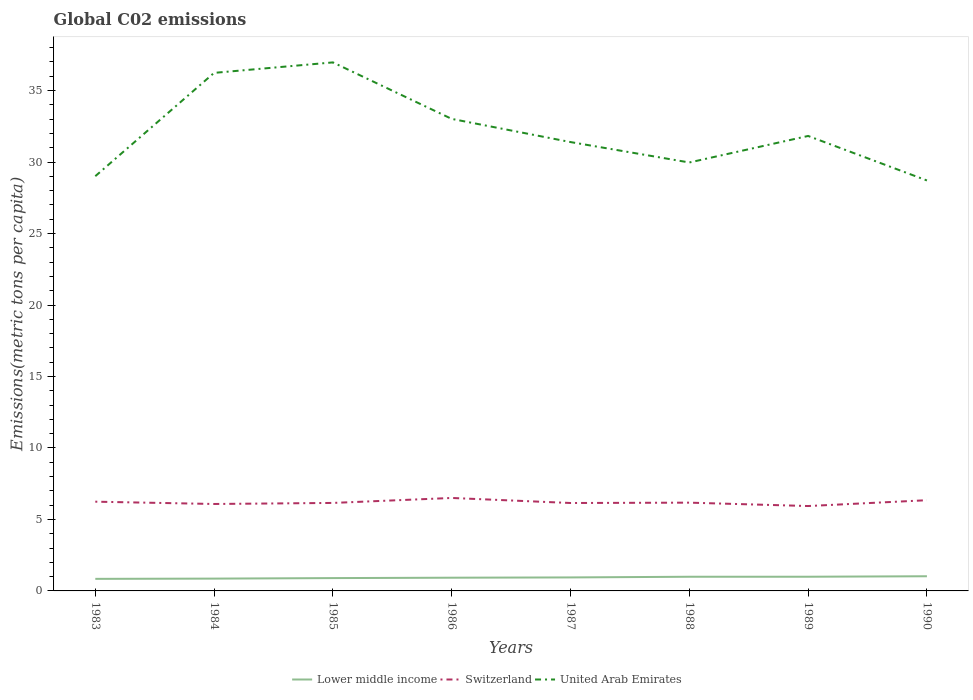Across all years, what is the maximum amount of CO2 emitted in in Lower middle income?
Ensure brevity in your answer.  0.84. What is the total amount of CO2 emitted in in Lower middle income in the graph?
Provide a succinct answer. -0.03. What is the difference between the highest and the second highest amount of CO2 emitted in in Lower middle income?
Give a very brief answer. 0.18. Is the amount of CO2 emitted in in Switzerland strictly greater than the amount of CO2 emitted in in Lower middle income over the years?
Offer a terse response. No. How many years are there in the graph?
Give a very brief answer. 8. How are the legend labels stacked?
Give a very brief answer. Horizontal. What is the title of the graph?
Provide a short and direct response. Global C02 emissions. What is the label or title of the X-axis?
Offer a terse response. Years. What is the label or title of the Y-axis?
Offer a terse response. Emissions(metric tons per capita). What is the Emissions(metric tons per capita) of Lower middle income in 1983?
Your response must be concise. 0.84. What is the Emissions(metric tons per capita) of Switzerland in 1983?
Provide a succinct answer. 6.24. What is the Emissions(metric tons per capita) of United Arab Emirates in 1983?
Keep it short and to the point. 29.01. What is the Emissions(metric tons per capita) of Lower middle income in 1984?
Keep it short and to the point. 0.86. What is the Emissions(metric tons per capita) in Switzerland in 1984?
Give a very brief answer. 6.08. What is the Emissions(metric tons per capita) in United Arab Emirates in 1984?
Your answer should be compact. 36.24. What is the Emissions(metric tons per capita) of Lower middle income in 1985?
Your answer should be very brief. 0.9. What is the Emissions(metric tons per capita) of Switzerland in 1985?
Your answer should be very brief. 6.16. What is the Emissions(metric tons per capita) in United Arab Emirates in 1985?
Ensure brevity in your answer.  36.97. What is the Emissions(metric tons per capita) in Lower middle income in 1986?
Your answer should be very brief. 0.92. What is the Emissions(metric tons per capita) in Switzerland in 1986?
Make the answer very short. 6.5. What is the Emissions(metric tons per capita) in United Arab Emirates in 1986?
Your answer should be very brief. 33.02. What is the Emissions(metric tons per capita) of Lower middle income in 1987?
Your response must be concise. 0.94. What is the Emissions(metric tons per capita) of Switzerland in 1987?
Keep it short and to the point. 6.15. What is the Emissions(metric tons per capita) in United Arab Emirates in 1987?
Offer a terse response. 31.4. What is the Emissions(metric tons per capita) in Lower middle income in 1988?
Provide a short and direct response. 0.99. What is the Emissions(metric tons per capita) of Switzerland in 1988?
Offer a very short reply. 6.17. What is the Emissions(metric tons per capita) of United Arab Emirates in 1988?
Offer a very short reply. 29.97. What is the Emissions(metric tons per capita) of Lower middle income in 1989?
Keep it short and to the point. 0.99. What is the Emissions(metric tons per capita) in Switzerland in 1989?
Give a very brief answer. 5.94. What is the Emissions(metric tons per capita) of United Arab Emirates in 1989?
Ensure brevity in your answer.  31.82. What is the Emissions(metric tons per capita) of Lower middle income in 1990?
Your answer should be compact. 1.03. What is the Emissions(metric tons per capita) in Switzerland in 1990?
Your answer should be very brief. 6.35. What is the Emissions(metric tons per capita) of United Arab Emirates in 1990?
Provide a succinct answer. 28.71. Across all years, what is the maximum Emissions(metric tons per capita) of Lower middle income?
Offer a terse response. 1.03. Across all years, what is the maximum Emissions(metric tons per capita) of Switzerland?
Your answer should be compact. 6.5. Across all years, what is the maximum Emissions(metric tons per capita) of United Arab Emirates?
Offer a terse response. 36.97. Across all years, what is the minimum Emissions(metric tons per capita) of Lower middle income?
Provide a succinct answer. 0.84. Across all years, what is the minimum Emissions(metric tons per capita) of Switzerland?
Provide a short and direct response. 5.94. Across all years, what is the minimum Emissions(metric tons per capita) of United Arab Emirates?
Your answer should be very brief. 28.71. What is the total Emissions(metric tons per capita) of Lower middle income in the graph?
Your response must be concise. 7.48. What is the total Emissions(metric tons per capita) of Switzerland in the graph?
Give a very brief answer. 49.59. What is the total Emissions(metric tons per capita) in United Arab Emirates in the graph?
Your answer should be compact. 257.14. What is the difference between the Emissions(metric tons per capita) of Lower middle income in 1983 and that in 1984?
Your answer should be very brief. -0.02. What is the difference between the Emissions(metric tons per capita) of Switzerland in 1983 and that in 1984?
Your answer should be compact. 0.16. What is the difference between the Emissions(metric tons per capita) in United Arab Emirates in 1983 and that in 1984?
Offer a very short reply. -7.23. What is the difference between the Emissions(metric tons per capita) in Lower middle income in 1983 and that in 1985?
Provide a short and direct response. -0.05. What is the difference between the Emissions(metric tons per capita) in Switzerland in 1983 and that in 1985?
Offer a very short reply. 0.09. What is the difference between the Emissions(metric tons per capita) of United Arab Emirates in 1983 and that in 1985?
Give a very brief answer. -7.96. What is the difference between the Emissions(metric tons per capita) of Lower middle income in 1983 and that in 1986?
Provide a short and direct response. -0.08. What is the difference between the Emissions(metric tons per capita) of Switzerland in 1983 and that in 1986?
Offer a terse response. -0.26. What is the difference between the Emissions(metric tons per capita) in United Arab Emirates in 1983 and that in 1986?
Your answer should be very brief. -4.01. What is the difference between the Emissions(metric tons per capita) of Lower middle income in 1983 and that in 1987?
Keep it short and to the point. -0.1. What is the difference between the Emissions(metric tons per capita) in Switzerland in 1983 and that in 1987?
Keep it short and to the point. 0.09. What is the difference between the Emissions(metric tons per capita) of United Arab Emirates in 1983 and that in 1987?
Give a very brief answer. -2.39. What is the difference between the Emissions(metric tons per capita) in Lower middle income in 1983 and that in 1988?
Your answer should be compact. -0.15. What is the difference between the Emissions(metric tons per capita) in Switzerland in 1983 and that in 1988?
Make the answer very short. 0.07. What is the difference between the Emissions(metric tons per capita) in United Arab Emirates in 1983 and that in 1988?
Keep it short and to the point. -0.96. What is the difference between the Emissions(metric tons per capita) of Lower middle income in 1983 and that in 1989?
Make the answer very short. -0.15. What is the difference between the Emissions(metric tons per capita) in Switzerland in 1983 and that in 1989?
Your response must be concise. 0.3. What is the difference between the Emissions(metric tons per capita) in United Arab Emirates in 1983 and that in 1989?
Your answer should be compact. -2.81. What is the difference between the Emissions(metric tons per capita) in Lower middle income in 1983 and that in 1990?
Your answer should be compact. -0.18. What is the difference between the Emissions(metric tons per capita) in Switzerland in 1983 and that in 1990?
Your answer should be very brief. -0.1. What is the difference between the Emissions(metric tons per capita) in United Arab Emirates in 1983 and that in 1990?
Your response must be concise. 0.3. What is the difference between the Emissions(metric tons per capita) in Lower middle income in 1984 and that in 1985?
Make the answer very short. -0.04. What is the difference between the Emissions(metric tons per capita) of Switzerland in 1984 and that in 1985?
Give a very brief answer. -0.07. What is the difference between the Emissions(metric tons per capita) in United Arab Emirates in 1984 and that in 1985?
Offer a very short reply. -0.73. What is the difference between the Emissions(metric tons per capita) of Lower middle income in 1984 and that in 1986?
Provide a succinct answer. -0.06. What is the difference between the Emissions(metric tons per capita) in Switzerland in 1984 and that in 1986?
Provide a succinct answer. -0.42. What is the difference between the Emissions(metric tons per capita) of United Arab Emirates in 1984 and that in 1986?
Your response must be concise. 3.22. What is the difference between the Emissions(metric tons per capita) in Lower middle income in 1984 and that in 1987?
Offer a terse response. -0.08. What is the difference between the Emissions(metric tons per capita) in Switzerland in 1984 and that in 1987?
Ensure brevity in your answer.  -0.07. What is the difference between the Emissions(metric tons per capita) of United Arab Emirates in 1984 and that in 1987?
Provide a short and direct response. 4.84. What is the difference between the Emissions(metric tons per capita) of Lower middle income in 1984 and that in 1988?
Make the answer very short. -0.13. What is the difference between the Emissions(metric tons per capita) in Switzerland in 1984 and that in 1988?
Provide a succinct answer. -0.09. What is the difference between the Emissions(metric tons per capita) in United Arab Emirates in 1984 and that in 1988?
Provide a short and direct response. 6.27. What is the difference between the Emissions(metric tons per capita) in Lower middle income in 1984 and that in 1989?
Keep it short and to the point. -0.13. What is the difference between the Emissions(metric tons per capita) of Switzerland in 1984 and that in 1989?
Provide a succinct answer. 0.14. What is the difference between the Emissions(metric tons per capita) in United Arab Emirates in 1984 and that in 1989?
Offer a very short reply. 4.41. What is the difference between the Emissions(metric tons per capita) in Lower middle income in 1984 and that in 1990?
Your answer should be very brief. -0.16. What is the difference between the Emissions(metric tons per capita) in Switzerland in 1984 and that in 1990?
Provide a succinct answer. -0.26. What is the difference between the Emissions(metric tons per capita) in United Arab Emirates in 1984 and that in 1990?
Your response must be concise. 7.53. What is the difference between the Emissions(metric tons per capita) of Lower middle income in 1985 and that in 1986?
Ensure brevity in your answer.  -0.03. What is the difference between the Emissions(metric tons per capita) of Switzerland in 1985 and that in 1986?
Your response must be concise. -0.35. What is the difference between the Emissions(metric tons per capita) of United Arab Emirates in 1985 and that in 1986?
Provide a short and direct response. 3.95. What is the difference between the Emissions(metric tons per capita) in Lower middle income in 1985 and that in 1987?
Provide a succinct answer. -0.05. What is the difference between the Emissions(metric tons per capita) of Switzerland in 1985 and that in 1987?
Offer a terse response. 0.01. What is the difference between the Emissions(metric tons per capita) of United Arab Emirates in 1985 and that in 1987?
Ensure brevity in your answer.  5.57. What is the difference between the Emissions(metric tons per capita) of Lower middle income in 1985 and that in 1988?
Your answer should be compact. -0.09. What is the difference between the Emissions(metric tons per capita) in Switzerland in 1985 and that in 1988?
Ensure brevity in your answer.  -0.02. What is the difference between the Emissions(metric tons per capita) in United Arab Emirates in 1985 and that in 1988?
Give a very brief answer. 7. What is the difference between the Emissions(metric tons per capita) of Lower middle income in 1985 and that in 1989?
Your response must be concise. -0.09. What is the difference between the Emissions(metric tons per capita) of Switzerland in 1985 and that in 1989?
Your answer should be very brief. 0.22. What is the difference between the Emissions(metric tons per capita) in United Arab Emirates in 1985 and that in 1989?
Offer a very short reply. 5.15. What is the difference between the Emissions(metric tons per capita) in Lower middle income in 1985 and that in 1990?
Your answer should be compact. -0.13. What is the difference between the Emissions(metric tons per capita) of Switzerland in 1985 and that in 1990?
Your answer should be compact. -0.19. What is the difference between the Emissions(metric tons per capita) of United Arab Emirates in 1985 and that in 1990?
Your answer should be compact. 8.26. What is the difference between the Emissions(metric tons per capita) in Lower middle income in 1986 and that in 1987?
Provide a succinct answer. -0.02. What is the difference between the Emissions(metric tons per capita) in Switzerland in 1986 and that in 1987?
Make the answer very short. 0.35. What is the difference between the Emissions(metric tons per capita) of United Arab Emirates in 1986 and that in 1987?
Give a very brief answer. 1.62. What is the difference between the Emissions(metric tons per capita) in Lower middle income in 1986 and that in 1988?
Make the answer very short. -0.07. What is the difference between the Emissions(metric tons per capita) in Switzerland in 1986 and that in 1988?
Your answer should be compact. 0.33. What is the difference between the Emissions(metric tons per capita) of United Arab Emirates in 1986 and that in 1988?
Make the answer very short. 3.05. What is the difference between the Emissions(metric tons per capita) in Lower middle income in 1986 and that in 1989?
Ensure brevity in your answer.  -0.07. What is the difference between the Emissions(metric tons per capita) of Switzerland in 1986 and that in 1989?
Give a very brief answer. 0.56. What is the difference between the Emissions(metric tons per capita) of United Arab Emirates in 1986 and that in 1989?
Provide a succinct answer. 1.19. What is the difference between the Emissions(metric tons per capita) in Lower middle income in 1986 and that in 1990?
Your response must be concise. -0.1. What is the difference between the Emissions(metric tons per capita) in Switzerland in 1986 and that in 1990?
Make the answer very short. 0.16. What is the difference between the Emissions(metric tons per capita) in United Arab Emirates in 1986 and that in 1990?
Provide a short and direct response. 4.31. What is the difference between the Emissions(metric tons per capita) of Lower middle income in 1987 and that in 1988?
Offer a terse response. -0.05. What is the difference between the Emissions(metric tons per capita) in Switzerland in 1987 and that in 1988?
Provide a succinct answer. -0.02. What is the difference between the Emissions(metric tons per capita) in United Arab Emirates in 1987 and that in 1988?
Provide a short and direct response. 1.43. What is the difference between the Emissions(metric tons per capita) in Lower middle income in 1987 and that in 1989?
Your response must be concise. -0.05. What is the difference between the Emissions(metric tons per capita) in Switzerland in 1987 and that in 1989?
Your answer should be compact. 0.21. What is the difference between the Emissions(metric tons per capita) of United Arab Emirates in 1987 and that in 1989?
Provide a succinct answer. -0.43. What is the difference between the Emissions(metric tons per capita) in Lower middle income in 1987 and that in 1990?
Offer a terse response. -0.08. What is the difference between the Emissions(metric tons per capita) of Switzerland in 1987 and that in 1990?
Keep it short and to the point. -0.2. What is the difference between the Emissions(metric tons per capita) in United Arab Emirates in 1987 and that in 1990?
Give a very brief answer. 2.69. What is the difference between the Emissions(metric tons per capita) in Lower middle income in 1988 and that in 1989?
Offer a terse response. -0. What is the difference between the Emissions(metric tons per capita) in Switzerland in 1988 and that in 1989?
Offer a terse response. 0.24. What is the difference between the Emissions(metric tons per capita) in United Arab Emirates in 1988 and that in 1989?
Your response must be concise. -1.86. What is the difference between the Emissions(metric tons per capita) in Lower middle income in 1988 and that in 1990?
Offer a very short reply. -0.04. What is the difference between the Emissions(metric tons per capita) in Switzerland in 1988 and that in 1990?
Give a very brief answer. -0.17. What is the difference between the Emissions(metric tons per capita) in United Arab Emirates in 1988 and that in 1990?
Keep it short and to the point. 1.26. What is the difference between the Emissions(metric tons per capita) in Lower middle income in 1989 and that in 1990?
Ensure brevity in your answer.  -0.03. What is the difference between the Emissions(metric tons per capita) of Switzerland in 1989 and that in 1990?
Ensure brevity in your answer.  -0.41. What is the difference between the Emissions(metric tons per capita) in United Arab Emirates in 1989 and that in 1990?
Provide a succinct answer. 3.11. What is the difference between the Emissions(metric tons per capita) of Lower middle income in 1983 and the Emissions(metric tons per capita) of Switzerland in 1984?
Keep it short and to the point. -5.24. What is the difference between the Emissions(metric tons per capita) in Lower middle income in 1983 and the Emissions(metric tons per capita) in United Arab Emirates in 1984?
Provide a short and direct response. -35.39. What is the difference between the Emissions(metric tons per capita) in Switzerland in 1983 and the Emissions(metric tons per capita) in United Arab Emirates in 1984?
Offer a terse response. -30. What is the difference between the Emissions(metric tons per capita) in Lower middle income in 1983 and the Emissions(metric tons per capita) in Switzerland in 1985?
Offer a terse response. -5.31. What is the difference between the Emissions(metric tons per capita) of Lower middle income in 1983 and the Emissions(metric tons per capita) of United Arab Emirates in 1985?
Offer a terse response. -36.13. What is the difference between the Emissions(metric tons per capita) in Switzerland in 1983 and the Emissions(metric tons per capita) in United Arab Emirates in 1985?
Offer a terse response. -30.73. What is the difference between the Emissions(metric tons per capita) in Lower middle income in 1983 and the Emissions(metric tons per capita) in Switzerland in 1986?
Your response must be concise. -5.66. What is the difference between the Emissions(metric tons per capita) in Lower middle income in 1983 and the Emissions(metric tons per capita) in United Arab Emirates in 1986?
Offer a very short reply. -32.17. What is the difference between the Emissions(metric tons per capita) in Switzerland in 1983 and the Emissions(metric tons per capita) in United Arab Emirates in 1986?
Your response must be concise. -26.78. What is the difference between the Emissions(metric tons per capita) of Lower middle income in 1983 and the Emissions(metric tons per capita) of Switzerland in 1987?
Provide a succinct answer. -5.31. What is the difference between the Emissions(metric tons per capita) of Lower middle income in 1983 and the Emissions(metric tons per capita) of United Arab Emirates in 1987?
Provide a succinct answer. -30.55. What is the difference between the Emissions(metric tons per capita) of Switzerland in 1983 and the Emissions(metric tons per capita) of United Arab Emirates in 1987?
Keep it short and to the point. -25.16. What is the difference between the Emissions(metric tons per capita) of Lower middle income in 1983 and the Emissions(metric tons per capita) of Switzerland in 1988?
Offer a very short reply. -5.33. What is the difference between the Emissions(metric tons per capita) in Lower middle income in 1983 and the Emissions(metric tons per capita) in United Arab Emirates in 1988?
Make the answer very short. -29.13. What is the difference between the Emissions(metric tons per capita) of Switzerland in 1983 and the Emissions(metric tons per capita) of United Arab Emirates in 1988?
Keep it short and to the point. -23.73. What is the difference between the Emissions(metric tons per capita) of Lower middle income in 1983 and the Emissions(metric tons per capita) of Switzerland in 1989?
Provide a succinct answer. -5.09. What is the difference between the Emissions(metric tons per capita) of Lower middle income in 1983 and the Emissions(metric tons per capita) of United Arab Emirates in 1989?
Offer a terse response. -30.98. What is the difference between the Emissions(metric tons per capita) of Switzerland in 1983 and the Emissions(metric tons per capita) of United Arab Emirates in 1989?
Give a very brief answer. -25.58. What is the difference between the Emissions(metric tons per capita) in Lower middle income in 1983 and the Emissions(metric tons per capita) in Switzerland in 1990?
Your answer should be very brief. -5.5. What is the difference between the Emissions(metric tons per capita) of Lower middle income in 1983 and the Emissions(metric tons per capita) of United Arab Emirates in 1990?
Your answer should be very brief. -27.87. What is the difference between the Emissions(metric tons per capita) of Switzerland in 1983 and the Emissions(metric tons per capita) of United Arab Emirates in 1990?
Make the answer very short. -22.47. What is the difference between the Emissions(metric tons per capita) in Lower middle income in 1984 and the Emissions(metric tons per capita) in Switzerland in 1985?
Provide a short and direct response. -5.29. What is the difference between the Emissions(metric tons per capita) in Lower middle income in 1984 and the Emissions(metric tons per capita) in United Arab Emirates in 1985?
Your answer should be compact. -36.11. What is the difference between the Emissions(metric tons per capita) of Switzerland in 1984 and the Emissions(metric tons per capita) of United Arab Emirates in 1985?
Your response must be concise. -30.89. What is the difference between the Emissions(metric tons per capita) of Lower middle income in 1984 and the Emissions(metric tons per capita) of Switzerland in 1986?
Keep it short and to the point. -5.64. What is the difference between the Emissions(metric tons per capita) of Lower middle income in 1984 and the Emissions(metric tons per capita) of United Arab Emirates in 1986?
Your answer should be very brief. -32.16. What is the difference between the Emissions(metric tons per capita) of Switzerland in 1984 and the Emissions(metric tons per capita) of United Arab Emirates in 1986?
Give a very brief answer. -26.94. What is the difference between the Emissions(metric tons per capita) in Lower middle income in 1984 and the Emissions(metric tons per capita) in Switzerland in 1987?
Offer a terse response. -5.29. What is the difference between the Emissions(metric tons per capita) in Lower middle income in 1984 and the Emissions(metric tons per capita) in United Arab Emirates in 1987?
Ensure brevity in your answer.  -30.54. What is the difference between the Emissions(metric tons per capita) in Switzerland in 1984 and the Emissions(metric tons per capita) in United Arab Emirates in 1987?
Ensure brevity in your answer.  -25.32. What is the difference between the Emissions(metric tons per capita) of Lower middle income in 1984 and the Emissions(metric tons per capita) of Switzerland in 1988?
Give a very brief answer. -5.31. What is the difference between the Emissions(metric tons per capita) in Lower middle income in 1984 and the Emissions(metric tons per capita) in United Arab Emirates in 1988?
Keep it short and to the point. -29.11. What is the difference between the Emissions(metric tons per capita) of Switzerland in 1984 and the Emissions(metric tons per capita) of United Arab Emirates in 1988?
Your answer should be compact. -23.89. What is the difference between the Emissions(metric tons per capita) of Lower middle income in 1984 and the Emissions(metric tons per capita) of Switzerland in 1989?
Your answer should be very brief. -5.08. What is the difference between the Emissions(metric tons per capita) in Lower middle income in 1984 and the Emissions(metric tons per capita) in United Arab Emirates in 1989?
Ensure brevity in your answer.  -30.96. What is the difference between the Emissions(metric tons per capita) of Switzerland in 1984 and the Emissions(metric tons per capita) of United Arab Emirates in 1989?
Make the answer very short. -25.74. What is the difference between the Emissions(metric tons per capita) in Lower middle income in 1984 and the Emissions(metric tons per capita) in Switzerland in 1990?
Offer a very short reply. -5.48. What is the difference between the Emissions(metric tons per capita) in Lower middle income in 1984 and the Emissions(metric tons per capita) in United Arab Emirates in 1990?
Ensure brevity in your answer.  -27.85. What is the difference between the Emissions(metric tons per capita) in Switzerland in 1984 and the Emissions(metric tons per capita) in United Arab Emirates in 1990?
Give a very brief answer. -22.63. What is the difference between the Emissions(metric tons per capita) in Lower middle income in 1985 and the Emissions(metric tons per capita) in Switzerland in 1986?
Your answer should be very brief. -5.61. What is the difference between the Emissions(metric tons per capita) in Lower middle income in 1985 and the Emissions(metric tons per capita) in United Arab Emirates in 1986?
Provide a succinct answer. -32.12. What is the difference between the Emissions(metric tons per capita) in Switzerland in 1985 and the Emissions(metric tons per capita) in United Arab Emirates in 1986?
Give a very brief answer. -26.86. What is the difference between the Emissions(metric tons per capita) of Lower middle income in 1985 and the Emissions(metric tons per capita) of Switzerland in 1987?
Keep it short and to the point. -5.25. What is the difference between the Emissions(metric tons per capita) of Lower middle income in 1985 and the Emissions(metric tons per capita) of United Arab Emirates in 1987?
Make the answer very short. -30.5. What is the difference between the Emissions(metric tons per capita) in Switzerland in 1985 and the Emissions(metric tons per capita) in United Arab Emirates in 1987?
Give a very brief answer. -25.24. What is the difference between the Emissions(metric tons per capita) of Lower middle income in 1985 and the Emissions(metric tons per capita) of Switzerland in 1988?
Make the answer very short. -5.28. What is the difference between the Emissions(metric tons per capita) in Lower middle income in 1985 and the Emissions(metric tons per capita) in United Arab Emirates in 1988?
Keep it short and to the point. -29.07. What is the difference between the Emissions(metric tons per capita) in Switzerland in 1985 and the Emissions(metric tons per capita) in United Arab Emirates in 1988?
Keep it short and to the point. -23.81. What is the difference between the Emissions(metric tons per capita) in Lower middle income in 1985 and the Emissions(metric tons per capita) in Switzerland in 1989?
Give a very brief answer. -5.04. What is the difference between the Emissions(metric tons per capita) in Lower middle income in 1985 and the Emissions(metric tons per capita) in United Arab Emirates in 1989?
Give a very brief answer. -30.93. What is the difference between the Emissions(metric tons per capita) in Switzerland in 1985 and the Emissions(metric tons per capita) in United Arab Emirates in 1989?
Your answer should be very brief. -25.67. What is the difference between the Emissions(metric tons per capita) of Lower middle income in 1985 and the Emissions(metric tons per capita) of Switzerland in 1990?
Offer a very short reply. -5.45. What is the difference between the Emissions(metric tons per capita) of Lower middle income in 1985 and the Emissions(metric tons per capita) of United Arab Emirates in 1990?
Your answer should be very brief. -27.81. What is the difference between the Emissions(metric tons per capita) in Switzerland in 1985 and the Emissions(metric tons per capita) in United Arab Emirates in 1990?
Ensure brevity in your answer.  -22.56. What is the difference between the Emissions(metric tons per capita) of Lower middle income in 1986 and the Emissions(metric tons per capita) of Switzerland in 1987?
Your response must be concise. -5.23. What is the difference between the Emissions(metric tons per capita) in Lower middle income in 1986 and the Emissions(metric tons per capita) in United Arab Emirates in 1987?
Your answer should be very brief. -30.47. What is the difference between the Emissions(metric tons per capita) of Switzerland in 1986 and the Emissions(metric tons per capita) of United Arab Emirates in 1987?
Keep it short and to the point. -24.89. What is the difference between the Emissions(metric tons per capita) of Lower middle income in 1986 and the Emissions(metric tons per capita) of Switzerland in 1988?
Keep it short and to the point. -5.25. What is the difference between the Emissions(metric tons per capita) in Lower middle income in 1986 and the Emissions(metric tons per capita) in United Arab Emirates in 1988?
Offer a terse response. -29.05. What is the difference between the Emissions(metric tons per capita) of Switzerland in 1986 and the Emissions(metric tons per capita) of United Arab Emirates in 1988?
Your answer should be very brief. -23.47. What is the difference between the Emissions(metric tons per capita) in Lower middle income in 1986 and the Emissions(metric tons per capita) in Switzerland in 1989?
Offer a very short reply. -5.01. What is the difference between the Emissions(metric tons per capita) in Lower middle income in 1986 and the Emissions(metric tons per capita) in United Arab Emirates in 1989?
Ensure brevity in your answer.  -30.9. What is the difference between the Emissions(metric tons per capita) of Switzerland in 1986 and the Emissions(metric tons per capita) of United Arab Emirates in 1989?
Give a very brief answer. -25.32. What is the difference between the Emissions(metric tons per capita) of Lower middle income in 1986 and the Emissions(metric tons per capita) of Switzerland in 1990?
Provide a short and direct response. -5.42. What is the difference between the Emissions(metric tons per capita) in Lower middle income in 1986 and the Emissions(metric tons per capita) in United Arab Emirates in 1990?
Keep it short and to the point. -27.79. What is the difference between the Emissions(metric tons per capita) of Switzerland in 1986 and the Emissions(metric tons per capita) of United Arab Emirates in 1990?
Provide a succinct answer. -22.21. What is the difference between the Emissions(metric tons per capita) in Lower middle income in 1987 and the Emissions(metric tons per capita) in Switzerland in 1988?
Give a very brief answer. -5.23. What is the difference between the Emissions(metric tons per capita) in Lower middle income in 1987 and the Emissions(metric tons per capita) in United Arab Emirates in 1988?
Keep it short and to the point. -29.03. What is the difference between the Emissions(metric tons per capita) of Switzerland in 1987 and the Emissions(metric tons per capita) of United Arab Emirates in 1988?
Your answer should be very brief. -23.82. What is the difference between the Emissions(metric tons per capita) of Lower middle income in 1987 and the Emissions(metric tons per capita) of Switzerland in 1989?
Offer a very short reply. -4.99. What is the difference between the Emissions(metric tons per capita) of Lower middle income in 1987 and the Emissions(metric tons per capita) of United Arab Emirates in 1989?
Your response must be concise. -30.88. What is the difference between the Emissions(metric tons per capita) of Switzerland in 1987 and the Emissions(metric tons per capita) of United Arab Emirates in 1989?
Your response must be concise. -25.67. What is the difference between the Emissions(metric tons per capita) in Lower middle income in 1987 and the Emissions(metric tons per capita) in Switzerland in 1990?
Offer a terse response. -5.4. What is the difference between the Emissions(metric tons per capita) of Lower middle income in 1987 and the Emissions(metric tons per capita) of United Arab Emirates in 1990?
Provide a succinct answer. -27.77. What is the difference between the Emissions(metric tons per capita) of Switzerland in 1987 and the Emissions(metric tons per capita) of United Arab Emirates in 1990?
Provide a succinct answer. -22.56. What is the difference between the Emissions(metric tons per capita) in Lower middle income in 1988 and the Emissions(metric tons per capita) in Switzerland in 1989?
Make the answer very short. -4.95. What is the difference between the Emissions(metric tons per capita) of Lower middle income in 1988 and the Emissions(metric tons per capita) of United Arab Emirates in 1989?
Offer a terse response. -30.83. What is the difference between the Emissions(metric tons per capita) of Switzerland in 1988 and the Emissions(metric tons per capita) of United Arab Emirates in 1989?
Offer a terse response. -25.65. What is the difference between the Emissions(metric tons per capita) of Lower middle income in 1988 and the Emissions(metric tons per capita) of Switzerland in 1990?
Keep it short and to the point. -5.35. What is the difference between the Emissions(metric tons per capita) of Lower middle income in 1988 and the Emissions(metric tons per capita) of United Arab Emirates in 1990?
Make the answer very short. -27.72. What is the difference between the Emissions(metric tons per capita) in Switzerland in 1988 and the Emissions(metric tons per capita) in United Arab Emirates in 1990?
Provide a short and direct response. -22.54. What is the difference between the Emissions(metric tons per capita) in Lower middle income in 1989 and the Emissions(metric tons per capita) in Switzerland in 1990?
Your answer should be very brief. -5.35. What is the difference between the Emissions(metric tons per capita) in Lower middle income in 1989 and the Emissions(metric tons per capita) in United Arab Emirates in 1990?
Give a very brief answer. -27.72. What is the difference between the Emissions(metric tons per capita) of Switzerland in 1989 and the Emissions(metric tons per capita) of United Arab Emirates in 1990?
Make the answer very short. -22.77. What is the average Emissions(metric tons per capita) in Lower middle income per year?
Your answer should be compact. 0.94. What is the average Emissions(metric tons per capita) in Switzerland per year?
Your answer should be compact. 6.2. What is the average Emissions(metric tons per capita) in United Arab Emirates per year?
Your response must be concise. 32.14. In the year 1983, what is the difference between the Emissions(metric tons per capita) in Lower middle income and Emissions(metric tons per capita) in Switzerland?
Provide a succinct answer. -5.4. In the year 1983, what is the difference between the Emissions(metric tons per capita) in Lower middle income and Emissions(metric tons per capita) in United Arab Emirates?
Keep it short and to the point. -28.17. In the year 1983, what is the difference between the Emissions(metric tons per capita) in Switzerland and Emissions(metric tons per capita) in United Arab Emirates?
Provide a succinct answer. -22.77. In the year 1984, what is the difference between the Emissions(metric tons per capita) in Lower middle income and Emissions(metric tons per capita) in Switzerland?
Offer a very short reply. -5.22. In the year 1984, what is the difference between the Emissions(metric tons per capita) in Lower middle income and Emissions(metric tons per capita) in United Arab Emirates?
Provide a succinct answer. -35.38. In the year 1984, what is the difference between the Emissions(metric tons per capita) of Switzerland and Emissions(metric tons per capita) of United Arab Emirates?
Provide a short and direct response. -30.16. In the year 1985, what is the difference between the Emissions(metric tons per capita) in Lower middle income and Emissions(metric tons per capita) in Switzerland?
Your answer should be very brief. -5.26. In the year 1985, what is the difference between the Emissions(metric tons per capita) in Lower middle income and Emissions(metric tons per capita) in United Arab Emirates?
Make the answer very short. -36.07. In the year 1985, what is the difference between the Emissions(metric tons per capita) in Switzerland and Emissions(metric tons per capita) in United Arab Emirates?
Provide a short and direct response. -30.82. In the year 1986, what is the difference between the Emissions(metric tons per capita) in Lower middle income and Emissions(metric tons per capita) in Switzerland?
Give a very brief answer. -5.58. In the year 1986, what is the difference between the Emissions(metric tons per capita) in Lower middle income and Emissions(metric tons per capita) in United Arab Emirates?
Offer a very short reply. -32.09. In the year 1986, what is the difference between the Emissions(metric tons per capita) of Switzerland and Emissions(metric tons per capita) of United Arab Emirates?
Provide a succinct answer. -26.52. In the year 1987, what is the difference between the Emissions(metric tons per capita) of Lower middle income and Emissions(metric tons per capita) of Switzerland?
Keep it short and to the point. -5.21. In the year 1987, what is the difference between the Emissions(metric tons per capita) of Lower middle income and Emissions(metric tons per capita) of United Arab Emirates?
Your answer should be very brief. -30.45. In the year 1987, what is the difference between the Emissions(metric tons per capita) in Switzerland and Emissions(metric tons per capita) in United Arab Emirates?
Give a very brief answer. -25.25. In the year 1988, what is the difference between the Emissions(metric tons per capita) in Lower middle income and Emissions(metric tons per capita) in Switzerland?
Keep it short and to the point. -5.18. In the year 1988, what is the difference between the Emissions(metric tons per capita) of Lower middle income and Emissions(metric tons per capita) of United Arab Emirates?
Provide a short and direct response. -28.98. In the year 1988, what is the difference between the Emissions(metric tons per capita) of Switzerland and Emissions(metric tons per capita) of United Arab Emirates?
Your answer should be very brief. -23.79. In the year 1989, what is the difference between the Emissions(metric tons per capita) of Lower middle income and Emissions(metric tons per capita) of Switzerland?
Make the answer very short. -4.95. In the year 1989, what is the difference between the Emissions(metric tons per capita) in Lower middle income and Emissions(metric tons per capita) in United Arab Emirates?
Provide a short and direct response. -30.83. In the year 1989, what is the difference between the Emissions(metric tons per capita) of Switzerland and Emissions(metric tons per capita) of United Arab Emirates?
Your response must be concise. -25.89. In the year 1990, what is the difference between the Emissions(metric tons per capita) of Lower middle income and Emissions(metric tons per capita) of Switzerland?
Provide a short and direct response. -5.32. In the year 1990, what is the difference between the Emissions(metric tons per capita) of Lower middle income and Emissions(metric tons per capita) of United Arab Emirates?
Your answer should be very brief. -27.69. In the year 1990, what is the difference between the Emissions(metric tons per capita) in Switzerland and Emissions(metric tons per capita) in United Arab Emirates?
Make the answer very short. -22.37. What is the ratio of the Emissions(metric tons per capita) of Lower middle income in 1983 to that in 1984?
Your answer should be compact. 0.98. What is the ratio of the Emissions(metric tons per capita) of Switzerland in 1983 to that in 1984?
Keep it short and to the point. 1.03. What is the ratio of the Emissions(metric tons per capita) in United Arab Emirates in 1983 to that in 1984?
Offer a terse response. 0.8. What is the ratio of the Emissions(metric tons per capita) of Lower middle income in 1983 to that in 1985?
Keep it short and to the point. 0.94. What is the ratio of the Emissions(metric tons per capita) of Switzerland in 1983 to that in 1985?
Keep it short and to the point. 1.01. What is the ratio of the Emissions(metric tons per capita) of United Arab Emirates in 1983 to that in 1985?
Keep it short and to the point. 0.78. What is the ratio of the Emissions(metric tons per capita) in Switzerland in 1983 to that in 1986?
Provide a short and direct response. 0.96. What is the ratio of the Emissions(metric tons per capita) in United Arab Emirates in 1983 to that in 1986?
Offer a terse response. 0.88. What is the ratio of the Emissions(metric tons per capita) of Lower middle income in 1983 to that in 1987?
Ensure brevity in your answer.  0.89. What is the ratio of the Emissions(metric tons per capita) in Switzerland in 1983 to that in 1987?
Make the answer very short. 1.01. What is the ratio of the Emissions(metric tons per capita) of United Arab Emirates in 1983 to that in 1987?
Your answer should be compact. 0.92. What is the ratio of the Emissions(metric tons per capita) in Lower middle income in 1983 to that in 1988?
Keep it short and to the point. 0.85. What is the ratio of the Emissions(metric tons per capita) of United Arab Emirates in 1983 to that in 1988?
Offer a terse response. 0.97. What is the ratio of the Emissions(metric tons per capita) of Lower middle income in 1983 to that in 1989?
Ensure brevity in your answer.  0.85. What is the ratio of the Emissions(metric tons per capita) of Switzerland in 1983 to that in 1989?
Provide a succinct answer. 1.05. What is the ratio of the Emissions(metric tons per capita) of United Arab Emirates in 1983 to that in 1989?
Provide a succinct answer. 0.91. What is the ratio of the Emissions(metric tons per capita) of Lower middle income in 1983 to that in 1990?
Ensure brevity in your answer.  0.82. What is the ratio of the Emissions(metric tons per capita) in Switzerland in 1983 to that in 1990?
Make the answer very short. 0.98. What is the ratio of the Emissions(metric tons per capita) of United Arab Emirates in 1983 to that in 1990?
Keep it short and to the point. 1.01. What is the ratio of the Emissions(metric tons per capita) of Lower middle income in 1984 to that in 1985?
Ensure brevity in your answer.  0.96. What is the ratio of the Emissions(metric tons per capita) in United Arab Emirates in 1984 to that in 1985?
Make the answer very short. 0.98. What is the ratio of the Emissions(metric tons per capita) in Lower middle income in 1984 to that in 1986?
Your answer should be very brief. 0.93. What is the ratio of the Emissions(metric tons per capita) of Switzerland in 1984 to that in 1986?
Offer a very short reply. 0.94. What is the ratio of the Emissions(metric tons per capita) in United Arab Emirates in 1984 to that in 1986?
Your answer should be very brief. 1.1. What is the ratio of the Emissions(metric tons per capita) of Lower middle income in 1984 to that in 1987?
Provide a succinct answer. 0.91. What is the ratio of the Emissions(metric tons per capita) in United Arab Emirates in 1984 to that in 1987?
Give a very brief answer. 1.15. What is the ratio of the Emissions(metric tons per capita) of Lower middle income in 1984 to that in 1988?
Keep it short and to the point. 0.87. What is the ratio of the Emissions(metric tons per capita) of Switzerland in 1984 to that in 1988?
Your response must be concise. 0.98. What is the ratio of the Emissions(metric tons per capita) of United Arab Emirates in 1984 to that in 1988?
Offer a very short reply. 1.21. What is the ratio of the Emissions(metric tons per capita) in Lower middle income in 1984 to that in 1989?
Your answer should be compact. 0.87. What is the ratio of the Emissions(metric tons per capita) of Switzerland in 1984 to that in 1989?
Offer a very short reply. 1.02. What is the ratio of the Emissions(metric tons per capita) in United Arab Emirates in 1984 to that in 1989?
Offer a terse response. 1.14. What is the ratio of the Emissions(metric tons per capita) of Lower middle income in 1984 to that in 1990?
Offer a terse response. 0.84. What is the ratio of the Emissions(metric tons per capita) in Switzerland in 1984 to that in 1990?
Give a very brief answer. 0.96. What is the ratio of the Emissions(metric tons per capita) of United Arab Emirates in 1984 to that in 1990?
Your response must be concise. 1.26. What is the ratio of the Emissions(metric tons per capita) in Lower middle income in 1985 to that in 1986?
Your answer should be compact. 0.97. What is the ratio of the Emissions(metric tons per capita) of Switzerland in 1985 to that in 1986?
Your response must be concise. 0.95. What is the ratio of the Emissions(metric tons per capita) in United Arab Emirates in 1985 to that in 1986?
Provide a succinct answer. 1.12. What is the ratio of the Emissions(metric tons per capita) in Lower middle income in 1985 to that in 1987?
Keep it short and to the point. 0.95. What is the ratio of the Emissions(metric tons per capita) in United Arab Emirates in 1985 to that in 1987?
Ensure brevity in your answer.  1.18. What is the ratio of the Emissions(metric tons per capita) of Lower middle income in 1985 to that in 1988?
Make the answer very short. 0.91. What is the ratio of the Emissions(metric tons per capita) in United Arab Emirates in 1985 to that in 1988?
Give a very brief answer. 1.23. What is the ratio of the Emissions(metric tons per capita) in Lower middle income in 1985 to that in 1989?
Offer a terse response. 0.9. What is the ratio of the Emissions(metric tons per capita) in Switzerland in 1985 to that in 1989?
Offer a terse response. 1.04. What is the ratio of the Emissions(metric tons per capita) of United Arab Emirates in 1985 to that in 1989?
Provide a short and direct response. 1.16. What is the ratio of the Emissions(metric tons per capita) of Lower middle income in 1985 to that in 1990?
Your answer should be compact. 0.87. What is the ratio of the Emissions(metric tons per capita) in Switzerland in 1985 to that in 1990?
Make the answer very short. 0.97. What is the ratio of the Emissions(metric tons per capita) in United Arab Emirates in 1985 to that in 1990?
Your response must be concise. 1.29. What is the ratio of the Emissions(metric tons per capita) in Lower middle income in 1986 to that in 1987?
Offer a very short reply. 0.98. What is the ratio of the Emissions(metric tons per capita) of Switzerland in 1986 to that in 1987?
Make the answer very short. 1.06. What is the ratio of the Emissions(metric tons per capita) in United Arab Emirates in 1986 to that in 1987?
Offer a terse response. 1.05. What is the ratio of the Emissions(metric tons per capita) in Lower middle income in 1986 to that in 1988?
Your answer should be very brief. 0.93. What is the ratio of the Emissions(metric tons per capita) in Switzerland in 1986 to that in 1988?
Your answer should be compact. 1.05. What is the ratio of the Emissions(metric tons per capita) in United Arab Emirates in 1986 to that in 1988?
Make the answer very short. 1.1. What is the ratio of the Emissions(metric tons per capita) of Lower middle income in 1986 to that in 1989?
Provide a succinct answer. 0.93. What is the ratio of the Emissions(metric tons per capita) of Switzerland in 1986 to that in 1989?
Provide a succinct answer. 1.1. What is the ratio of the Emissions(metric tons per capita) in United Arab Emirates in 1986 to that in 1989?
Your answer should be very brief. 1.04. What is the ratio of the Emissions(metric tons per capita) in Lower middle income in 1986 to that in 1990?
Provide a succinct answer. 0.9. What is the ratio of the Emissions(metric tons per capita) in Switzerland in 1986 to that in 1990?
Provide a short and direct response. 1.02. What is the ratio of the Emissions(metric tons per capita) in United Arab Emirates in 1986 to that in 1990?
Offer a very short reply. 1.15. What is the ratio of the Emissions(metric tons per capita) in Lower middle income in 1987 to that in 1988?
Your answer should be very brief. 0.95. What is the ratio of the Emissions(metric tons per capita) of United Arab Emirates in 1987 to that in 1988?
Your answer should be very brief. 1.05. What is the ratio of the Emissions(metric tons per capita) of Lower middle income in 1987 to that in 1989?
Your answer should be very brief. 0.95. What is the ratio of the Emissions(metric tons per capita) of Switzerland in 1987 to that in 1989?
Ensure brevity in your answer.  1.04. What is the ratio of the Emissions(metric tons per capita) in United Arab Emirates in 1987 to that in 1989?
Offer a terse response. 0.99. What is the ratio of the Emissions(metric tons per capita) of Lower middle income in 1987 to that in 1990?
Offer a terse response. 0.92. What is the ratio of the Emissions(metric tons per capita) of Switzerland in 1987 to that in 1990?
Your answer should be compact. 0.97. What is the ratio of the Emissions(metric tons per capita) in United Arab Emirates in 1987 to that in 1990?
Keep it short and to the point. 1.09. What is the ratio of the Emissions(metric tons per capita) in Lower middle income in 1988 to that in 1989?
Offer a very short reply. 1. What is the ratio of the Emissions(metric tons per capita) in Switzerland in 1988 to that in 1989?
Offer a very short reply. 1.04. What is the ratio of the Emissions(metric tons per capita) of United Arab Emirates in 1988 to that in 1989?
Make the answer very short. 0.94. What is the ratio of the Emissions(metric tons per capita) in Lower middle income in 1988 to that in 1990?
Your response must be concise. 0.97. What is the ratio of the Emissions(metric tons per capita) in Switzerland in 1988 to that in 1990?
Ensure brevity in your answer.  0.97. What is the ratio of the Emissions(metric tons per capita) of United Arab Emirates in 1988 to that in 1990?
Offer a terse response. 1.04. What is the ratio of the Emissions(metric tons per capita) of Lower middle income in 1989 to that in 1990?
Keep it short and to the point. 0.97. What is the ratio of the Emissions(metric tons per capita) of Switzerland in 1989 to that in 1990?
Your answer should be very brief. 0.94. What is the ratio of the Emissions(metric tons per capita) in United Arab Emirates in 1989 to that in 1990?
Ensure brevity in your answer.  1.11. What is the difference between the highest and the second highest Emissions(metric tons per capita) in Lower middle income?
Keep it short and to the point. 0.03. What is the difference between the highest and the second highest Emissions(metric tons per capita) in Switzerland?
Keep it short and to the point. 0.16. What is the difference between the highest and the second highest Emissions(metric tons per capita) in United Arab Emirates?
Provide a short and direct response. 0.73. What is the difference between the highest and the lowest Emissions(metric tons per capita) of Lower middle income?
Give a very brief answer. 0.18. What is the difference between the highest and the lowest Emissions(metric tons per capita) in Switzerland?
Offer a very short reply. 0.56. What is the difference between the highest and the lowest Emissions(metric tons per capita) in United Arab Emirates?
Offer a very short reply. 8.26. 